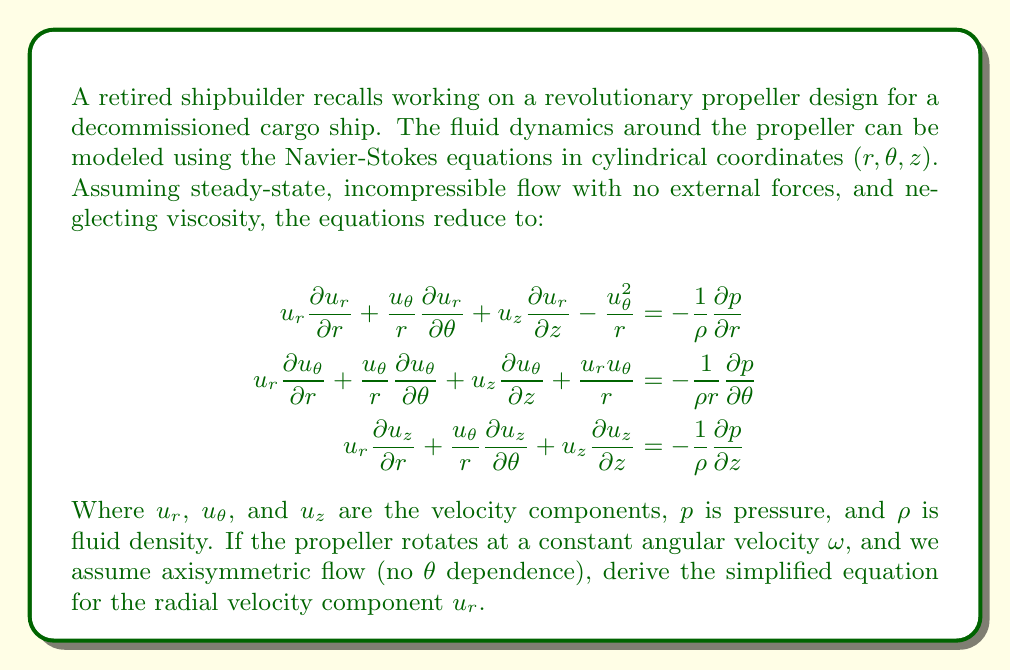Teach me how to tackle this problem. To simplify the Navier-Stokes equations for this scenario, we'll follow these steps:

1) First, we note that the flow is axisymmetric, which means there's no dependence on $\theta$. This eliminates all terms with $\frac{\partial}{\partial \theta}$.

2) The propeller rotates at a constant angular velocity $\omega$, so we can assume $u_\theta = r\omega$.

3) We'll focus on the equation for the radial velocity component $u_r$:

   $$u_r \frac{\partial u_r}{\partial r} + \frac{u_\theta}{r} \frac{\partial u_r}{\partial \theta} + u_z \frac{\partial u_r}{\partial z} - \frac{u_\theta^2}{r} = -\frac{1}{\rho} \frac{\partial p}{\partial r}$$

4) Applying the axisymmetric condition removes the $\frac{\partial u_r}{\partial \theta}$ term:

   $$u_r \frac{\partial u_r}{\partial r} + u_z \frac{\partial u_r}{\partial z} - \frac{u_\theta^2}{r} = -\frac{1}{\rho} \frac{\partial p}{\partial r}$$

5) Substituting $u_\theta = r\omega$:

   $$u_r \frac{\partial u_r}{\partial r} + u_z \frac{\partial u_r}{\partial z} - \frac{(r\omega)^2}{r} = -\frac{1}{\rho} \frac{\partial p}{\partial r}$$

6) Simplifying:

   $$u_r \frac{\partial u_r}{\partial r} + u_z \frac{\partial u_r}{\partial z} - r\omega^2 = -\frac{1}{\rho} \frac{\partial p}{\partial r}$$

This is the simplified equation for the radial velocity component $u_r$ under the given conditions.
Answer: $$u_r \frac{\partial u_r}{\partial r} + u_z \frac{\partial u_r}{\partial z} - r\omega^2 = -\frac{1}{\rho} \frac{\partial p}{\partial r}$$ 